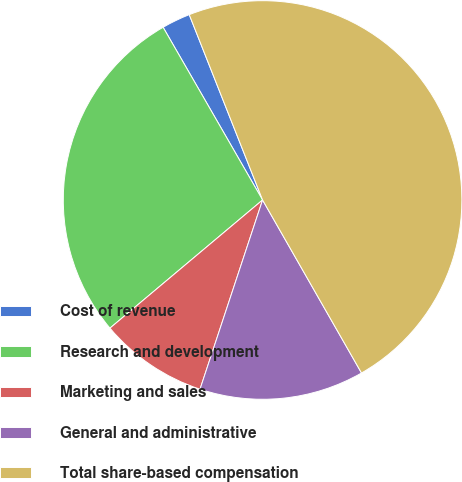Convert chart. <chart><loc_0><loc_0><loc_500><loc_500><pie_chart><fcel>Cost of revenue<fcel>Research and development<fcel>Marketing and sales<fcel>General and administrative<fcel>Total share-based compensation<nl><fcel>2.32%<fcel>27.8%<fcel>8.8%<fcel>13.35%<fcel>47.73%<nl></chart> 